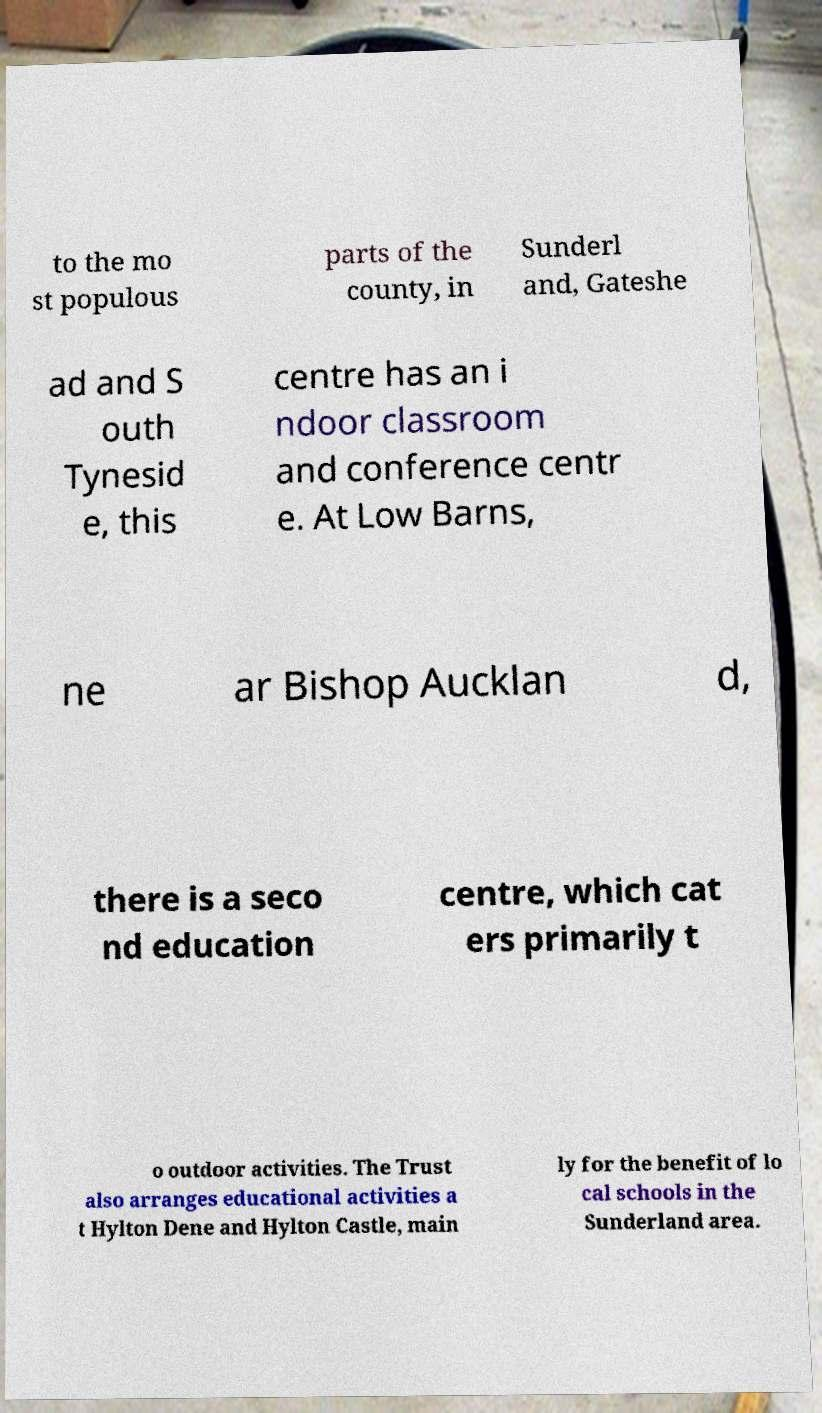What messages or text are displayed in this image? I need them in a readable, typed format. to the mo st populous parts of the county, in Sunderl and, Gateshe ad and S outh Tynesid e, this centre has an i ndoor classroom and conference centr e. At Low Barns, ne ar Bishop Aucklan d, there is a seco nd education centre, which cat ers primarily t o outdoor activities. The Trust also arranges educational activities a t Hylton Dene and Hylton Castle, main ly for the benefit of lo cal schools in the Sunderland area. 